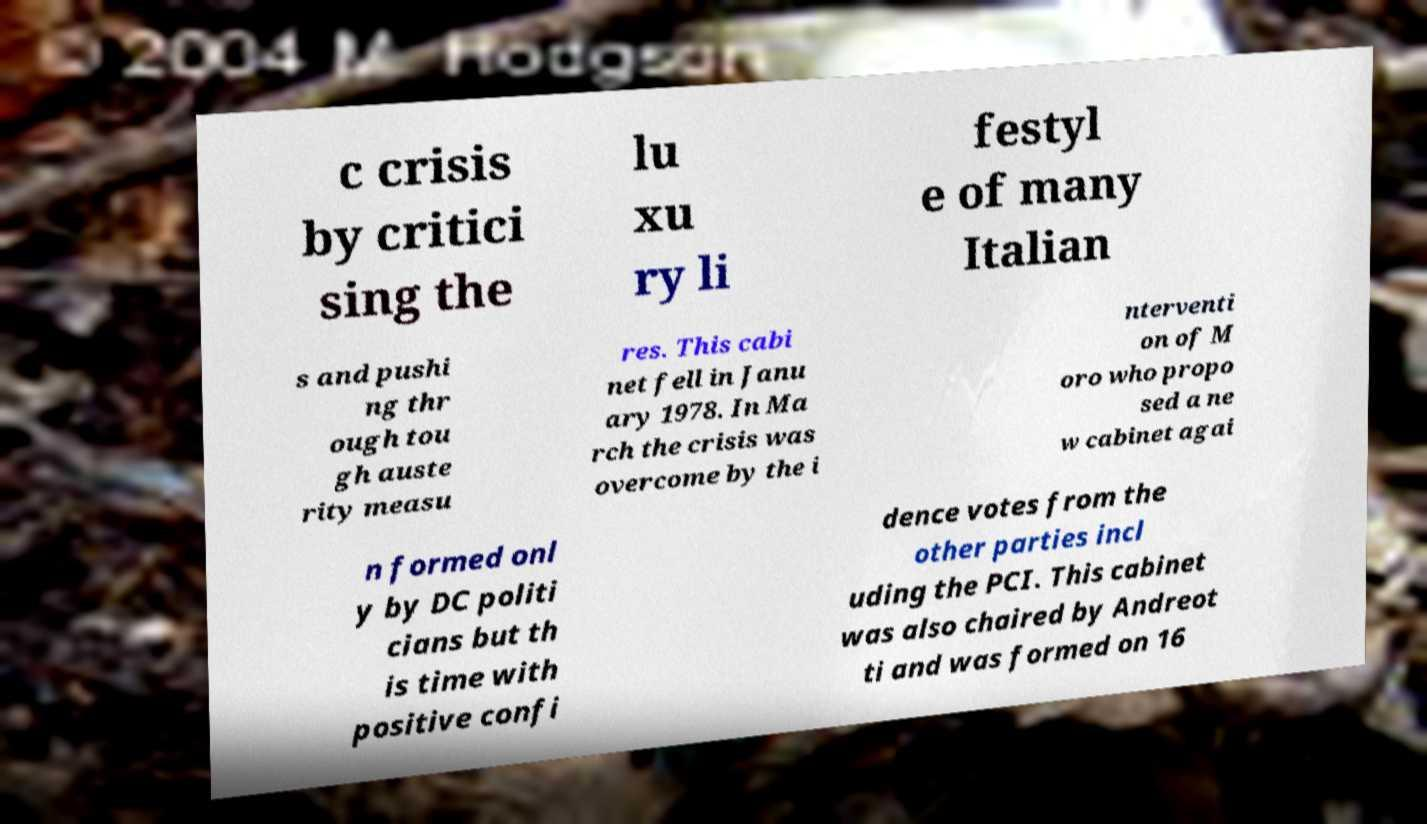What messages or text are displayed in this image? I need them in a readable, typed format. c crisis by critici sing the lu xu ry li festyl e of many Italian s and pushi ng thr ough tou gh auste rity measu res. This cabi net fell in Janu ary 1978. In Ma rch the crisis was overcome by the i nterventi on of M oro who propo sed a ne w cabinet agai n formed onl y by DC politi cians but th is time with positive confi dence votes from the other parties incl uding the PCI. This cabinet was also chaired by Andreot ti and was formed on 16 